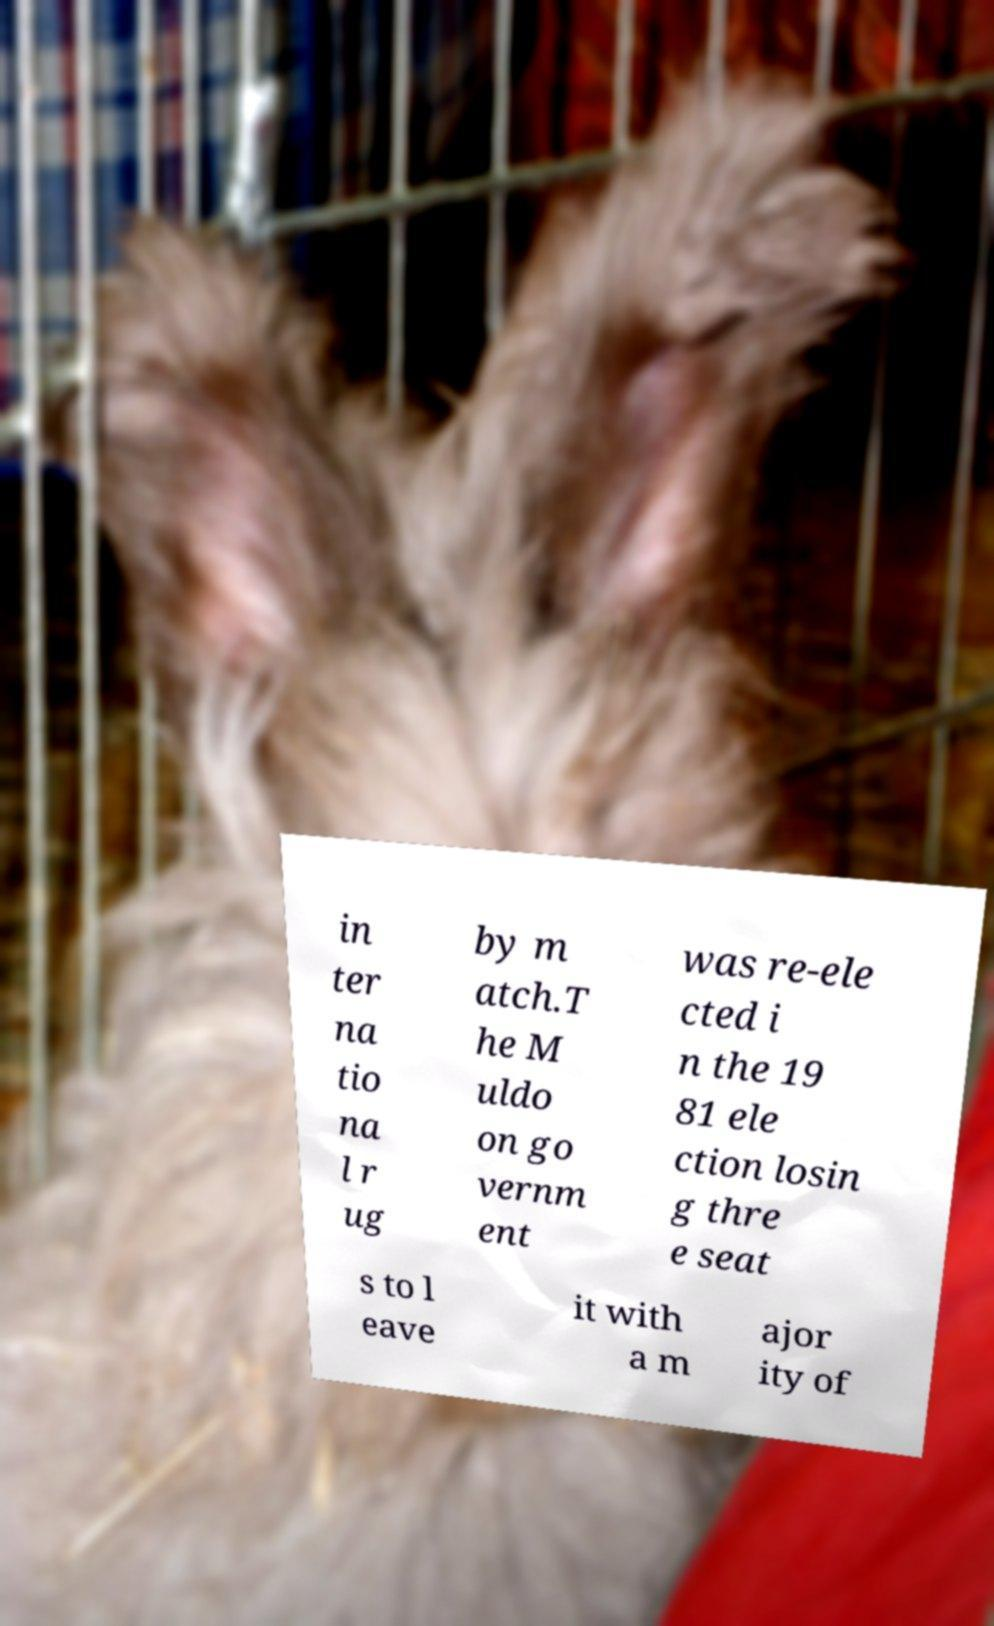Could you assist in decoding the text presented in this image and type it out clearly? in ter na tio na l r ug by m atch.T he M uldo on go vernm ent was re-ele cted i n the 19 81 ele ction losin g thre e seat s to l eave it with a m ajor ity of 